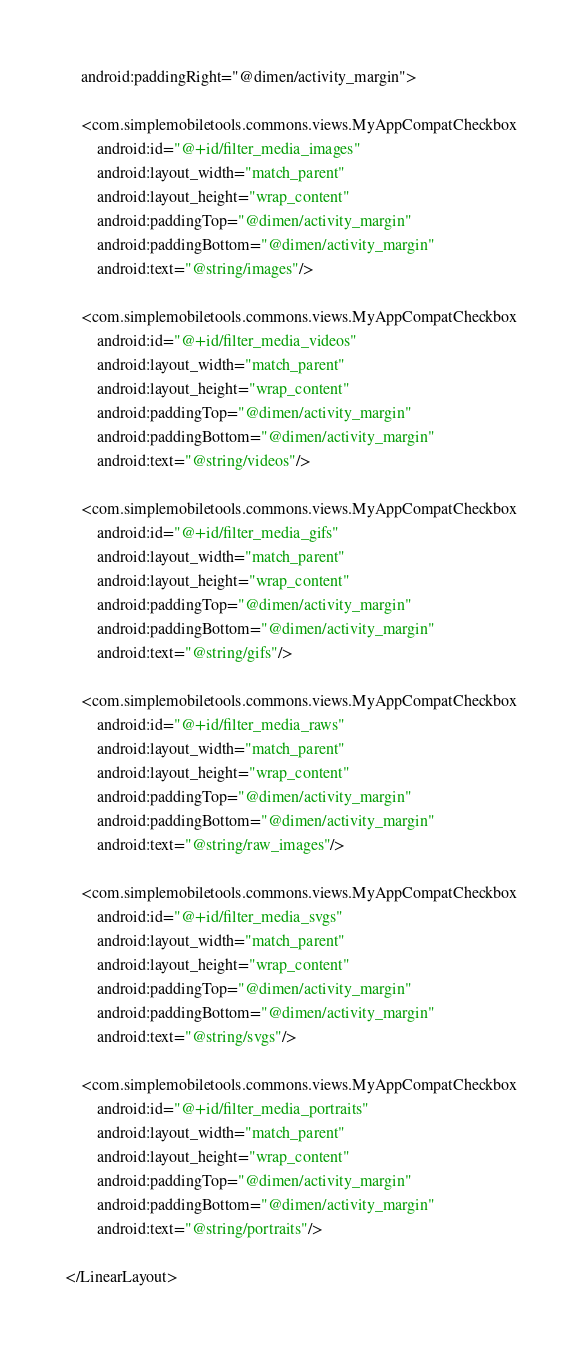<code> <loc_0><loc_0><loc_500><loc_500><_XML_>    android:paddingRight="@dimen/activity_margin">

    <com.simplemobiletools.commons.views.MyAppCompatCheckbox
        android:id="@+id/filter_media_images"
        android:layout_width="match_parent"
        android:layout_height="wrap_content"
        android:paddingTop="@dimen/activity_margin"
        android:paddingBottom="@dimen/activity_margin"
        android:text="@string/images"/>

    <com.simplemobiletools.commons.views.MyAppCompatCheckbox
        android:id="@+id/filter_media_videos"
        android:layout_width="match_parent"
        android:layout_height="wrap_content"
        android:paddingTop="@dimen/activity_margin"
        android:paddingBottom="@dimen/activity_margin"
        android:text="@string/videos"/>

    <com.simplemobiletools.commons.views.MyAppCompatCheckbox
        android:id="@+id/filter_media_gifs"
        android:layout_width="match_parent"
        android:layout_height="wrap_content"
        android:paddingTop="@dimen/activity_margin"
        android:paddingBottom="@dimen/activity_margin"
        android:text="@string/gifs"/>

    <com.simplemobiletools.commons.views.MyAppCompatCheckbox
        android:id="@+id/filter_media_raws"
        android:layout_width="match_parent"
        android:layout_height="wrap_content"
        android:paddingTop="@dimen/activity_margin"
        android:paddingBottom="@dimen/activity_margin"
        android:text="@string/raw_images"/>

    <com.simplemobiletools.commons.views.MyAppCompatCheckbox
        android:id="@+id/filter_media_svgs"
        android:layout_width="match_parent"
        android:layout_height="wrap_content"
        android:paddingTop="@dimen/activity_margin"
        android:paddingBottom="@dimen/activity_margin"
        android:text="@string/svgs"/>

    <com.simplemobiletools.commons.views.MyAppCompatCheckbox
        android:id="@+id/filter_media_portraits"
        android:layout_width="match_parent"
        android:layout_height="wrap_content"
        android:paddingTop="@dimen/activity_margin"
        android:paddingBottom="@dimen/activity_margin"
        android:text="@string/portraits"/>

</LinearLayout>
</code> 